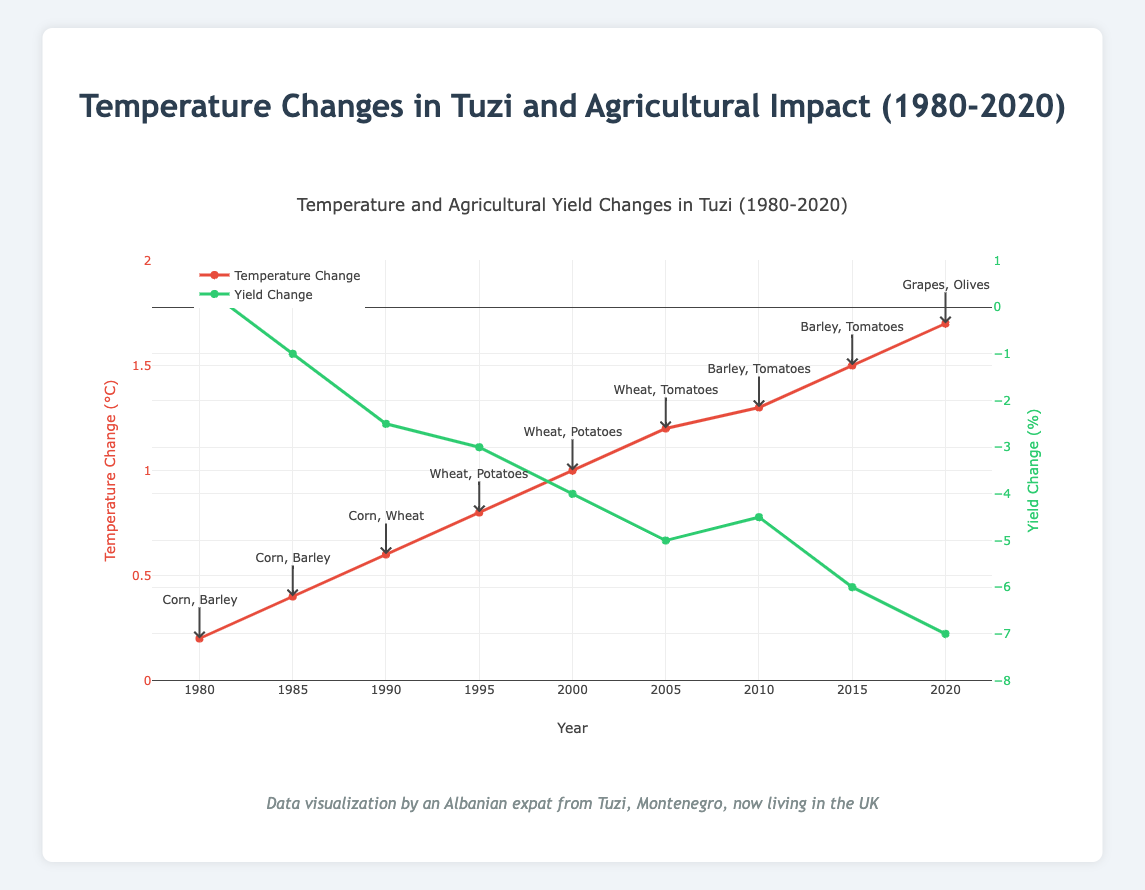what is the average temperature change from 1980 to 2020? The average temperature change is calculated by summing up all the temperature changes and dividing by the number of years. The sum is (0.2+0.4+0.6+0.8+1.0+1.2+1.3+1.5+1.7) = 8.7. There are 9 years, so the average is 8.7 / 9 = 0.966
Answer: 0.966 how did temperature change and yield change compare in 1985 and 2005? In 1985, the temperature change was 0.4°C and yield change was -1.0%. In 2005, the temperature change was 1.2°C and yield change was -5.0%. Comparing these values: the temperature increased by 1.2 - 0.4 = 0.8°C, and the yield change decreased by -1.0 - (-5.0) = 4.0%.
Answer: Temperature increased by 0.8°C, yield change decreased by 4.0% what is the largest decrease in yield change? The largest decrease in yield change is identified by finding the most negative yield change percentage. The minimum value is -7.0% in 2020
Answer: -7.0% which two years have the greatest difference in temperature change? The year with the highest temperature change is 2020 (1.7°C) and the year with the lowest is 1980 (0.2°C). The difference is 1.7 - 0.2 = 1.5°C
Answer: 1980 and 2020 how did the main crops change between 1990 and 2020? In 1990, the main crops were Corn and Wheat. In 2020, the main crops were Grapes and Olives.
Answer: From Corn and Wheat to Grapes and Olives what color represents temperature change on the plot? The visual plot shows temperature change with a red line, as seen from the color used in the trace description.
Answer: Red compare the yield change between 2010 and 2015 In 2010, the yield change was -4.5%, while in 2015 it was -6.0%. The decrease is calculated as -6.0% - (-4.5%) = -1.5%.
Answer: Yield change decreased by 1.5% how many crops are listed as main crops across all years? By listing all the main crops and removing duplicates: Corn, Barley, Wheat, Potatoes, Tomatoes, Grapes, Olives, there are 7 different crops.
Answer: 7 what is the first year to have a temperature change of 1°C or more? By scanning the temperature changes, the first year with a 1°C change or more is 2000 with exactly 1.0°C.
Answer: 2000 